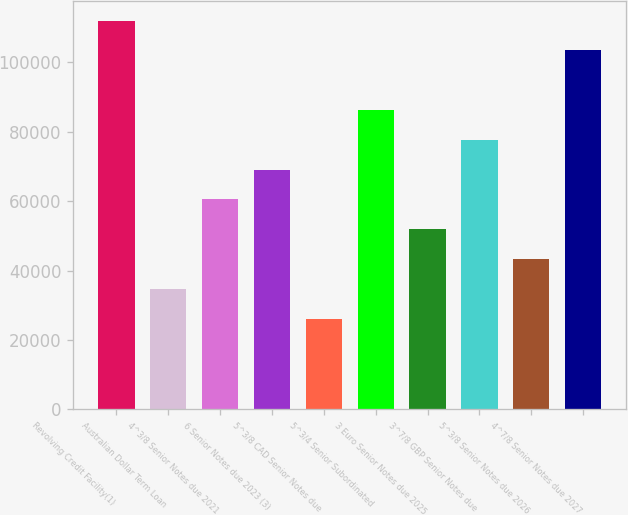Convert chart. <chart><loc_0><loc_0><loc_500><loc_500><bar_chart><fcel>Revolving Credit Facility(1)<fcel>Australian Dollar Term Loan<fcel>4^3/8 Senior Notes due 2021<fcel>6 Senior Notes due 2023 (3)<fcel>5^3/8 CAD Senior Notes due<fcel>5^3/4 Senior Subordinated<fcel>3 Euro Senior Notes due 2025<fcel>3^7/8 GBP Senior Notes due<fcel>5^3/8 Senior Notes due 2026<fcel>4^7/8 Senior Notes due 2027<nl><fcel>112005<fcel>34709.6<fcel>60474.8<fcel>69063.2<fcel>26121.2<fcel>86240<fcel>51886.4<fcel>77651.6<fcel>43298<fcel>103417<nl></chart> 